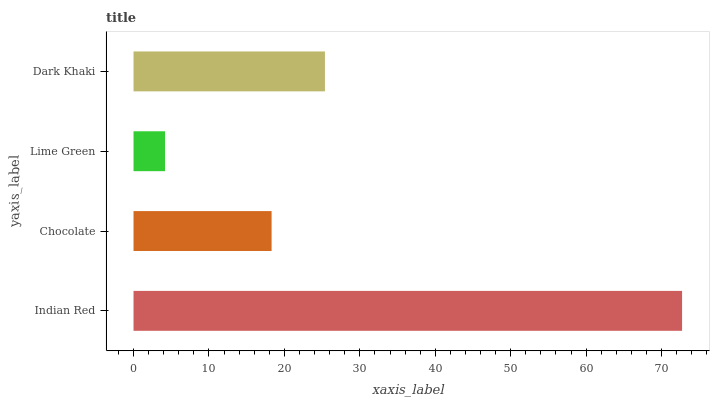Is Lime Green the minimum?
Answer yes or no. Yes. Is Indian Red the maximum?
Answer yes or no. Yes. Is Chocolate the minimum?
Answer yes or no. No. Is Chocolate the maximum?
Answer yes or no. No. Is Indian Red greater than Chocolate?
Answer yes or no. Yes. Is Chocolate less than Indian Red?
Answer yes or no. Yes. Is Chocolate greater than Indian Red?
Answer yes or no. No. Is Indian Red less than Chocolate?
Answer yes or no. No. Is Dark Khaki the high median?
Answer yes or no. Yes. Is Chocolate the low median?
Answer yes or no. Yes. Is Lime Green the high median?
Answer yes or no. No. Is Indian Red the low median?
Answer yes or no. No. 